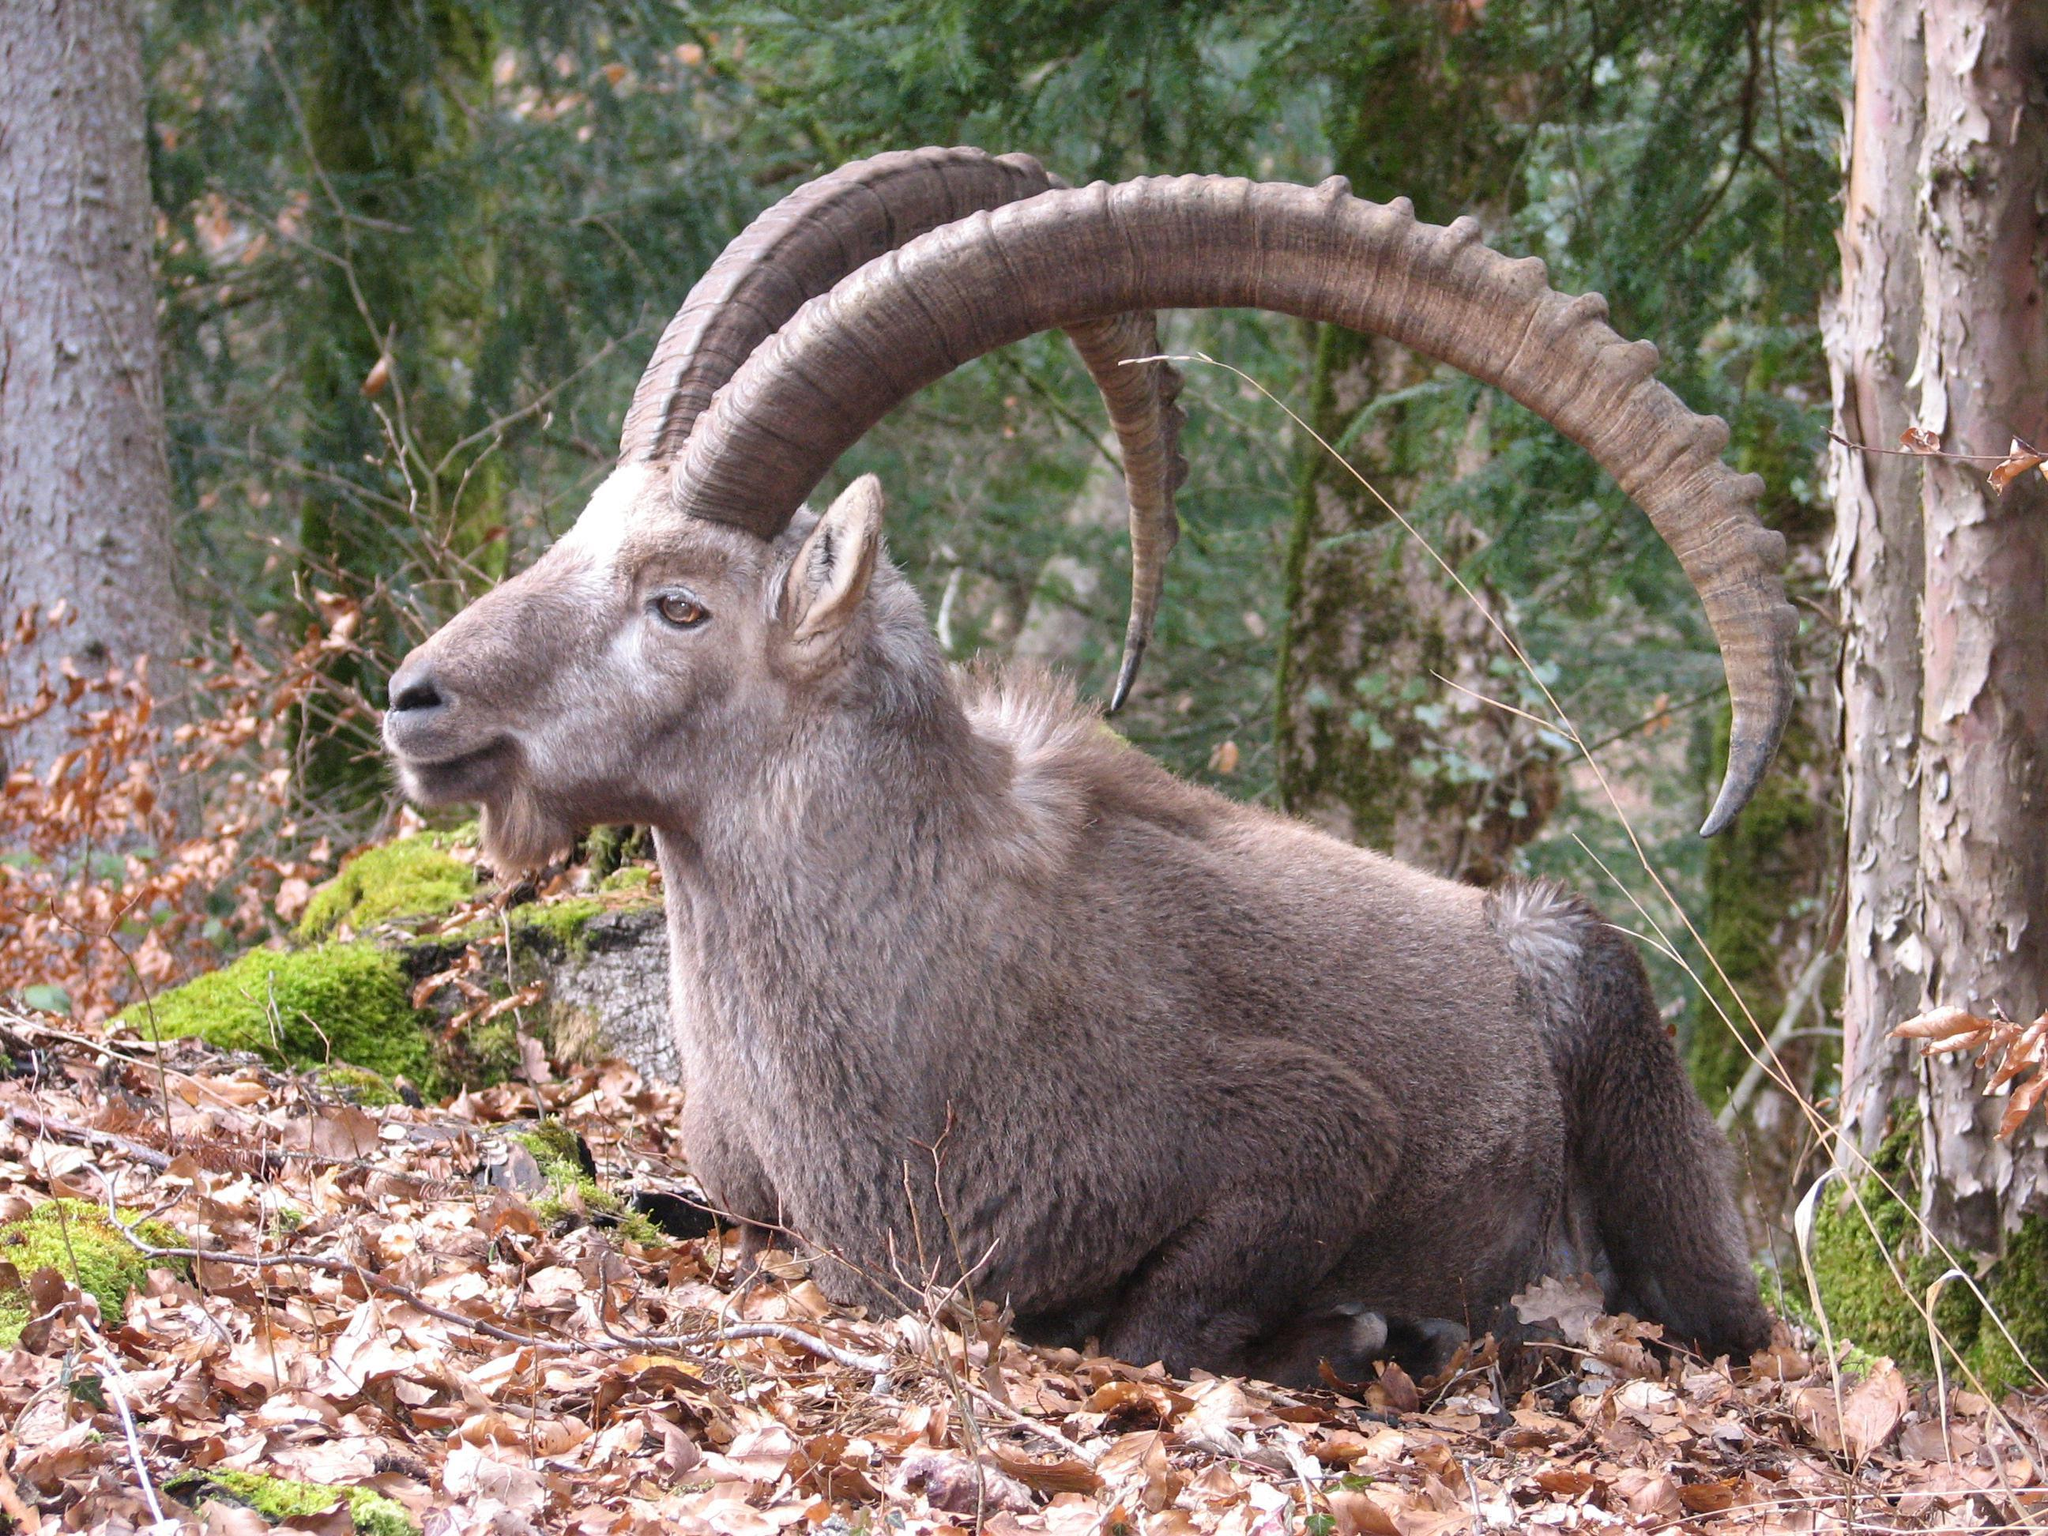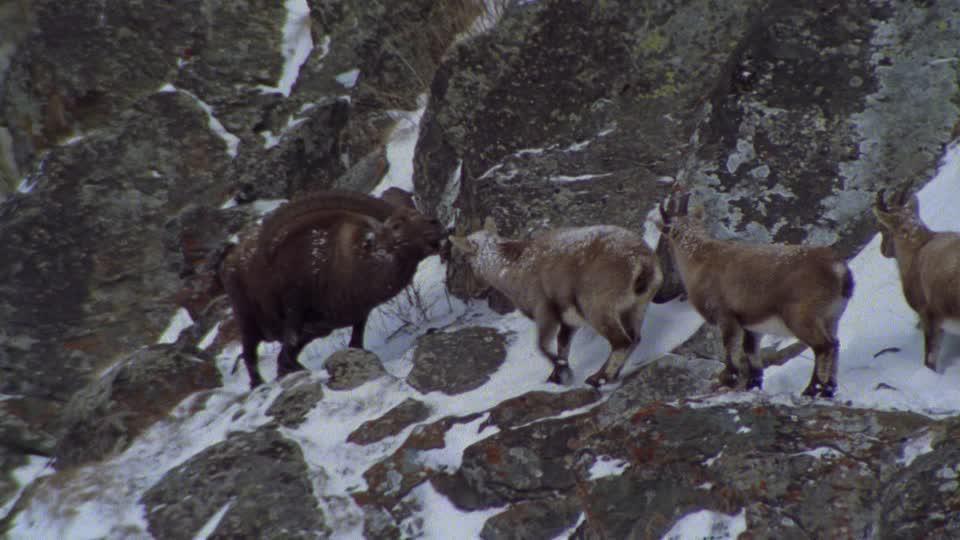The first image is the image on the left, the second image is the image on the right. Given the left and right images, does the statement "There is snow visible." hold true? Answer yes or no. Yes. 